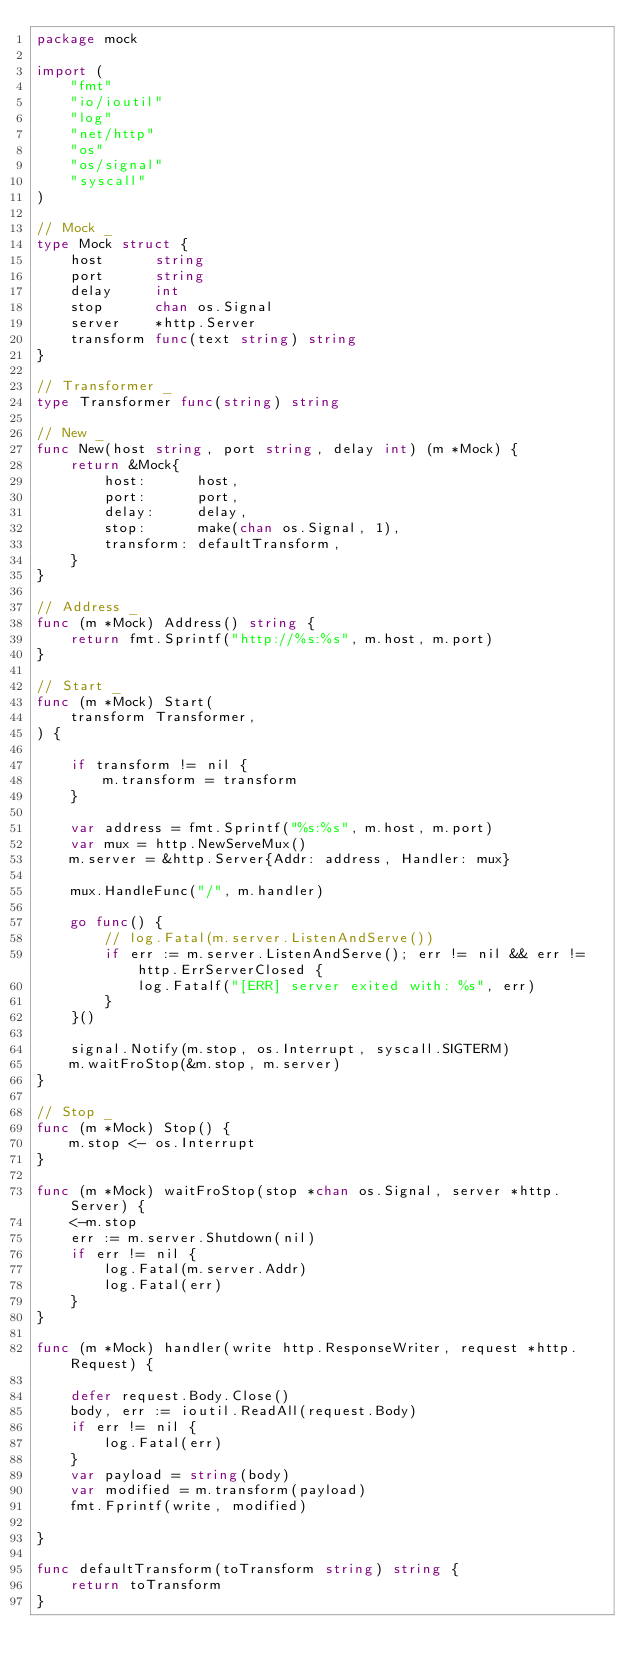Convert code to text. <code><loc_0><loc_0><loc_500><loc_500><_Go_>package mock

import (
	"fmt"
	"io/ioutil"
	"log"
	"net/http"
	"os"
	"os/signal"
	"syscall"
)

// Mock _
type Mock struct {
	host      string
	port      string
	delay     int
	stop      chan os.Signal
	server    *http.Server
	transform func(text string) string
}

// Transformer _
type Transformer func(string) string

// New _
func New(host string, port string, delay int) (m *Mock) {
	return &Mock{
		host:      host,
		port:      port,
		delay:     delay,
		stop:      make(chan os.Signal, 1),
		transform: defaultTransform,
	}
}

// Address _
func (m *Mock) Address() string {
	return fmt.Sprintf("http://%s:%s", m.host, m.port)
}

// Start _
func (m *Mock) Start(
	transform Transformer,
) {

	if transform != nil {
		m.transform = transform
	}

	var address = fmt.Sprintf("%s:%s", m.host, m.port)
	var mux = http.NewServeMux()
	m.server = &http.Server{Addr: address, Handler: mux}

	mux.HandleFunc("/", m.handler)

	go func() {
		// log.Fatal(m.server.ListenAndServe())
		if err := m.server.ListenAndServe(); err != nil && err != http.ErrServerClosed {
			log.Fatalf("[ERR] server exited with: %s", err)
		}
	}()

	signal.Notify(m.stop, os.Interrupt, syscall.SIGTERM)
	m.waitFroStop(&m.stop, m.server)
}

// Stop _
func (m *Mock) Stop() {
	m.stop <- os.Interrupt
}

func (m *Mock) waitFroStop(stop *chan os.Signal, server *http.Server) {
	<-m.stop
	err := m.server.Shutdown(nil)
	if err != nil {
		log.Fatal(m.server.Addr)
		log.Fatal(err)
	}
}

func (m *Mock) handler(write http.ResponseWriter, request *http.Request) {

	defer request.Body.Close()
	body, err := ioutil.ReadAll(request.Body)
	if err != nil {
		log.Fatal(err)
	}
	var payload = string(body)
	var modified = m.transform(payload)
	fmt.Fprintf(write, modified)

}

func defaultTransform(toTransform string) string {
	return toTransform
}
</code> 